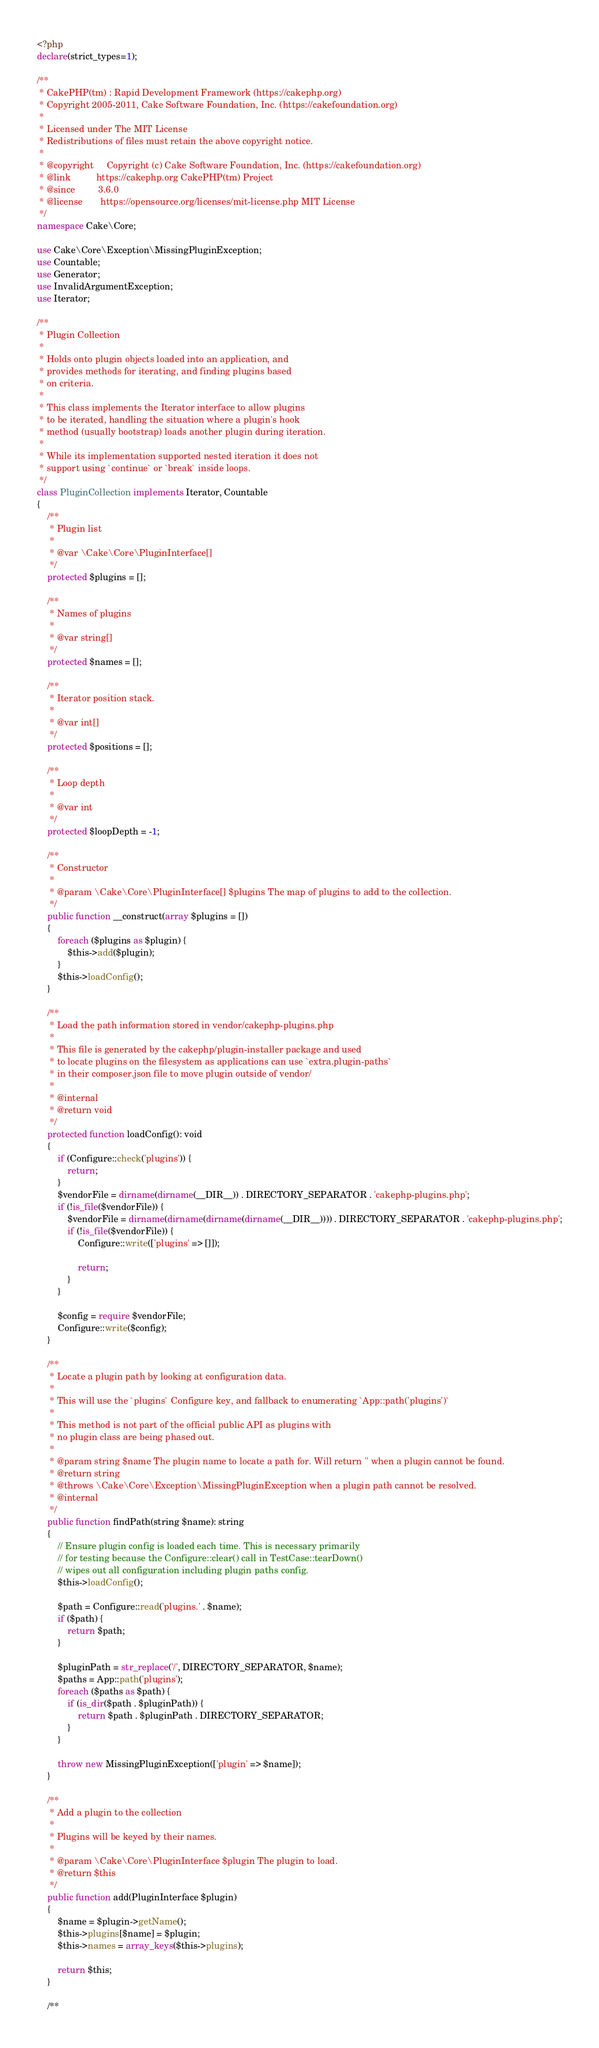<code> <loc_0><loc_0><loc_500><loc_500><_PHP_><?php
declare(strict_types=1);

/**
 * CakePHP(tm) : Rapid Development Framework (https://cakephp.org)
 * Copyright 2005-2011, Cake Software Foundation, Inc. (https://cakefoundation.org)
 *
 * Licensed under The MIT License
 * Redistributions of files must retain the above copyright notice.
 *
 * @copyright     Copyright (c) Cake Software Foundation, Inc. (https://cakefoundation.org)
 * @link          https://cakephp.org CakePHP(tm) Project
 * @since         3.6.0
 * @license       https://opensource.org/licenses/mit-license.php MIT License
 */
namespace Cake\Core;

use Cake\Core\Exception\MissingPluginException;
use Countable;
use Generator;
use InvalidArgumentException;
use Iterator;

/**
 * Plugin Collection
 *
 * Holds onto plugin objects loaded into an application, and
 * provides methods for iterating, and finding plugins based
 * on criteria.
 *
 * This class implements the Iterator interface to allow plugins
 * to be iterated, handling the situation where a plugin's hook
 * method (usually bootstrap) loads another plugin during iteration.
 *
 * While its implementation supported nested iteration it does not
 * support using `continue` or `break` inside loops.
 */
class PluginCollection implements Iterator, Countable
{
    /**
     * Plugin list
     *
     * @var \Cake\Core\PluginInterface[]
     */
    protected $plugins = [];

    /**
     * Names of plugins
     *
     * @var string[]
     */
    protected $names = [];

    /**
     * Iterator position stack.
     *
     * @var int[]
     */
    protected $positions = [];

    /**
     * Loop depth
     *
     * @var int
     */
    protected $loopDepth = -1;

    /**
     * Constructor
     *
     * @param \Cake\Core\PluginInterface[] $plugins The map of plugins to add to the collection.
     */
    public function __construct(array $plugins = [])
    {
        foreach ($plugins as $plugin) {
            $this->add($plugin);
        }
        $this->loadConfig();
    }

    /**
     * Load the path information stored in vendor/cakephp-plugins.php
     *
     * This file is generated by the cakephp/plugin-installer package and used
     * to locate plugins on the filesystem as applications can use `extra.plugin-paths`
     * in their composer.json file to move plugin outside of vendor/
     *
     * @internal
     * @return void
     */
    protected function loadConfig(): void
    {
        if (Configure::check('plugins')) {
            return;
        }
        $vendorFile = dirname(dirname(__DIR__)) . DIRECTORY_SEPARATOR . 'cakephp-plugins.php';
        if (!is_file($vendorFile)) {
            $vendorFile = dirname(dirname(dirname(dirname(__DIR__)))) . DIRECTORY_SEPARATOR . 'cakephp-plugins.php';
            if (!is_file($vendorFile)) {
                Configure::write(['plugins' => []]);

                return;
            }
        }

        $config = require $vendorFile;
        Configure::write($config);
    }

    /**
     * Locate a plugin path by looking at configuration data.
     *
     * This will use the `plugins` Configure key, and fallback to enumerating `App::path('plugins')`
     *
     * This method is not part of the official public API as plugins with
     * no plugin class are being phased out.
     *
     * @param string $name The plugin name to locate a path for. Will return '' when a plugin cannot be found.
     * @return string
     * @throws \Cake\Core\Exception\MissingPluginException when a plugin path cannot be resolved.
     * @internal
     */
    public function findPath(string $name): string
    {
        // Ensure plugin config is loaded each time. This is necessary primarily
        // for testing because the Configure::clear() call in TestCase::tearDown()
        // wipes out all configuration including plugin paths config.
        $this->loadConfig();

        $path = Configure::read('plugins.' . $name);
        if ($path) {
            return $path;
        }

        $pluginPath = str_replace('/', DIRECTORY_SEPARATOR, $name);
        $paths = App::path('plugins');
        foreach ($paths as $path) {
            if (is_dir($path . $pluginPath)) {
                return $path . $pluginPath . DIRECTORY_SEPARATOR;
            }
        }

        throw new MissingPluginException(['plugin' => $name]);
    }

    /**
     * Add a plugin to the collection
     *
     * Plugins will be keyed by their names.
     *
     * @param \Cake\Core\PluginInterface $plugin The plugin to load.
     * @return $this
     */
    public function add(PluginInterface $plugin)
    {
        $name = $plugin->getName();
        $this->plugins[$name] = $plugin;
        $this->names = array_keys($this->plugins);

        return $this;
    }

    /**</code> 